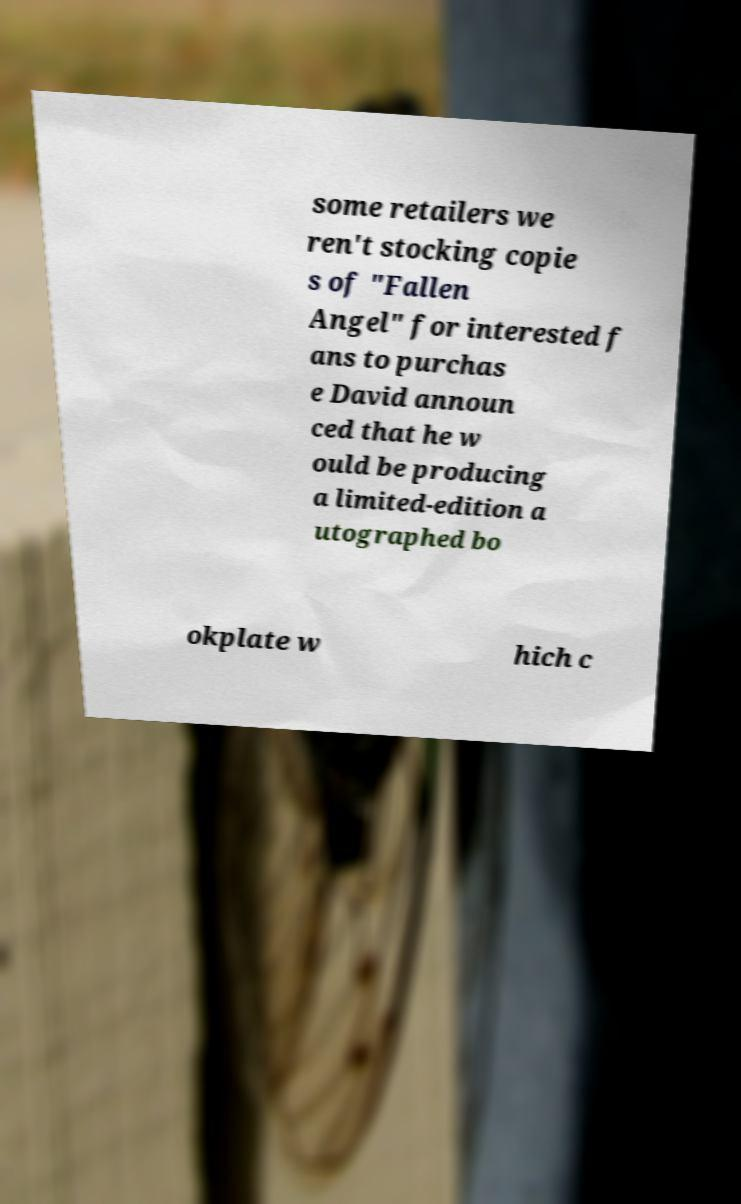What messages or text are displayed in this image? I need them in a readable, typed format. some retailers we ren't stocking copie s of "Fallen Angel" for interested f ans to purchas e David announ ced that he w ould be producing a limited-edition a utographed bo okplate w hich c 